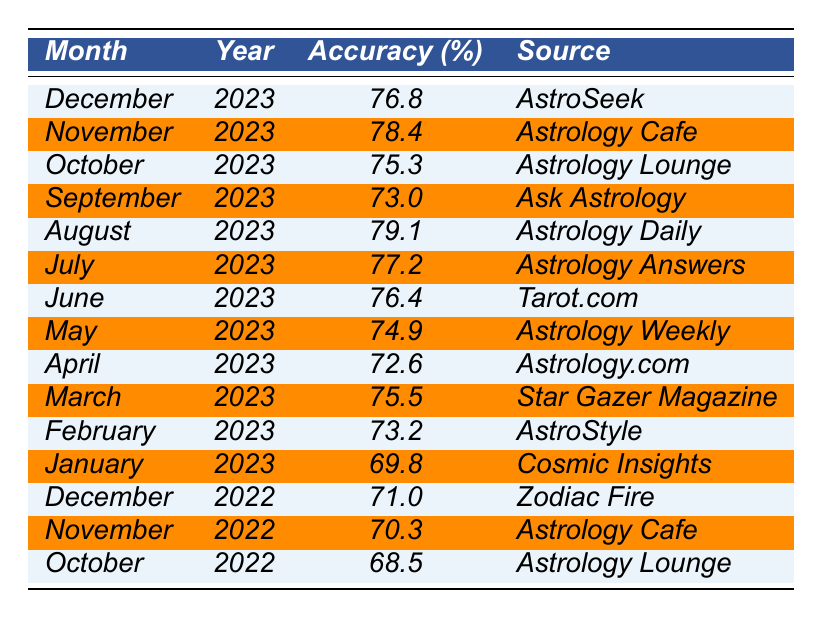What was the accuracy rate for December 2023? The table shows that the accuracy rate for December 2023 is listed directly, which is 76.8%.
Answer: 76.8% Which month in 2023 had the highest accuracy rate and what was it? Upon examining the table, August 2023 has the highest accuracy rate at 79.1%.
Answer: August 2023, 79.1% What is the average accuracy rate for the first quarter (January, February, March) of 2023? The accuracy rates for the first quarter of 2023 are 69.8%, 73.2%, and 75.5%. To find the average, we sum them (69.8 + 73.2 + 75.5 = 218.5) and divide by 3. Thus, the average accuracy rate is 218.5 / 3 = 72.83%.
Answer: 72.83% Did the accuracy rates for November and December 2022 exceed 70%? Referring to the table, the accuracy rates for November 2022 (70.3%) and December 2022 (71.0%) both exceed 70%.
Answer: Yes What was the change in accuracy rate from June 2022 to June 2023? The accuracy rate in June 2022 is 67.9% and in June 2023 it is 76.4%. The change can be calculated by subtracting (76.4 - 67.9 = 8.5%). Thus, the change in accuracy rate is an increase of 8.5 percentage points.
Answer: Increase of 8.5 points Is the accuracy rate for January 2023 higher than that of January 2021? Looking at the table, January 2023 has an accuracy rate of 69.8% while January 2021 has an accuracy rate of 65.9%. Therefore, January 2023's accuracy is indeed higher.
Answer: Yes What is the average accuracy rate for all months listed for 2022? To find the average for 2022, we sum the accuracy rates for January (67.3), February (75.1), March (71.8), April (69.4), May (74.2), June (67.9), July (72.0), August (70.7), September (74.0), October (68.5), November (70.3), and December (71.0), which totals 870.7. We then divide by 12 (870.7 / 12 = 72.5583).
Answer: 72.56 In which month of 2023 was the accuracy rate lowest, and what was the rate? From the table, the month with the lowest accuracy rate in 2023 is January with an accuracy rate of 69.8%.
Answer: January 2023, 69.8% How many months in 2021 had an accuracy rate higher than 75%? Reviewing the table data for 2021, the months with higher than 75% accuracy are March (75.9), June (78.8), August (75.2), October (76.1), and the total is 4 months.
Answer: 4 months What is the trend in accuracy rates from 2021 to 2023? By analyzing the table data: in 2021, the accuracy rates fluctuated between the high 60s to high 70s with the highest being June at 78.8%. In 2022, rates averaged around the low to mid 70s. In 2023, accuracy improved further with several months exceeding 75%, indicating a trend of increasing accuracy rates over this period.
Answer: Increasing trend 